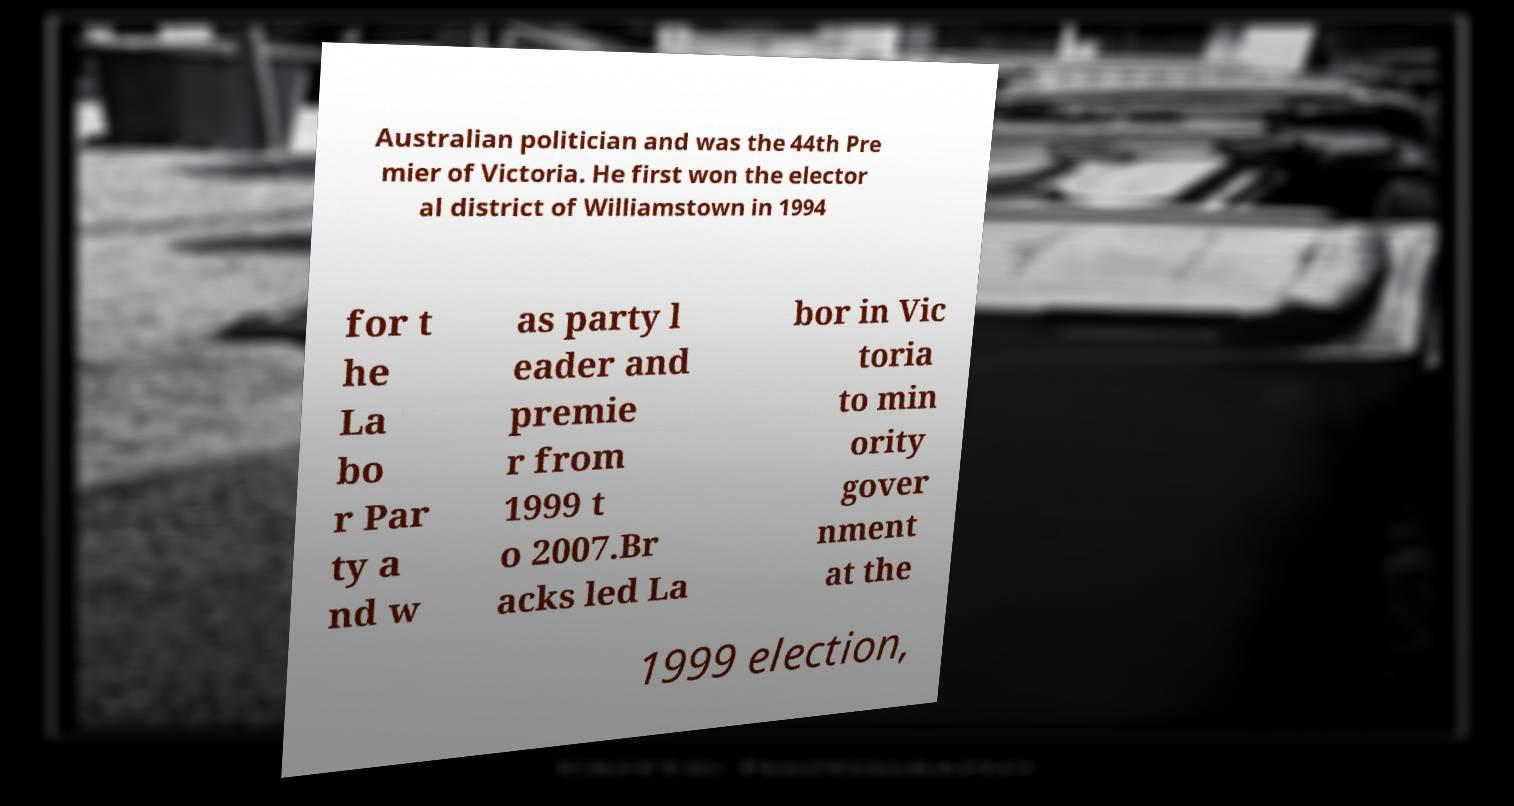There's text embedded in this image that I need extracted. Can you transcribe it verbatim? Australian politician and was the 44th Pre mier of Victoria. He first won the elector al district of Williamstown in 1994 for t he La bo r Par ty a nd w as party l eader and premie r from 1999 t o 2007.Br acks led La bor in Vic toria to min ority gover nment at the 1999 election, 